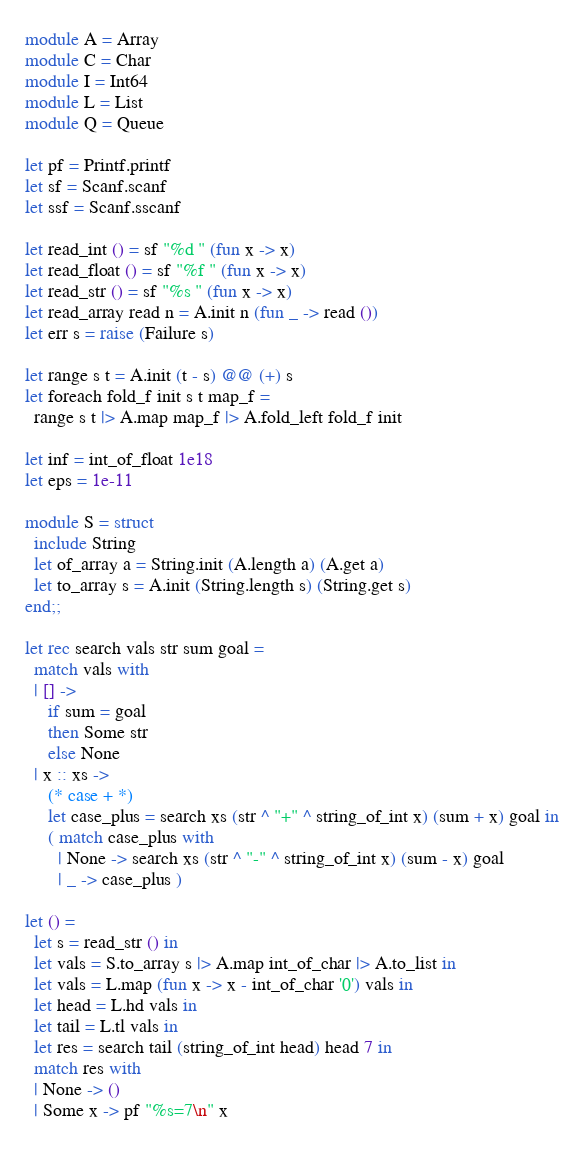<code> <loc_0><loc_0><loc_500><loc_500><_OCaml_>module A = Array
module C = Char
module I = Int64
module L = List
module Q = Queue

let pf = Printf.printf
let sf = Scanf.scanf
let ssf = Scanf.sscanf

let read_int () = sf "%d " (fun x -> x)
let read_float () = sf "%f " (fun x -> x)
let read_str () = sf "%s " (fun x -> x)
let read_array read n = A.init n (fun _ -> read ())
let err s = raise (Failure s)

let range s t = A.init (t - s) @@ (+) s
let foreach fold_f init s t map_f =
  range s t |> A.map map_f |> A.fold_left fold_f init

let inf = int_of_float 1e18
let eps = 1e-11

module S = struct
  include String
  let of_array a = String.init (A.length a) (A.get a)
  let to_array s = A.init (String.length s) (String.get s)
end;;

let rec search vals str sum goal =
  match vals with
  | [] ->
     if sum = goal
     then Some str
     else None
  | x :: xs ->
     (* case + *)
     let case_plus = search xs (str ^ "+" ^ string_of_int x) (sum + x) goal in
     ( match case_plus with
       | None -> search xs (str ^ "-" ^ string_of_int x) (sum - x) goal
       | _ -> case_plus )

let () =
  let s = read_str () in
  let vals = S.to_array s |> A.map int_of_char |> A.to_list in
  let vals = L.map (fun x -> x - int_of_char '0') vals in
  let head = L.hd vals in
  let tail = L.tl vals in
  let res = search tail (string_of_int head) head 7 in
  match res with
  | None -> ()
  | Some x -> pf "%s=7\n" x
  
</code> 